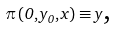Convert formula to latex. <formula><loc_0><loc_0><loc_500><loc_500>\pi \left ( 0 , y _ { 0 } , x \right ) \equiv y \text {,}</formula> 